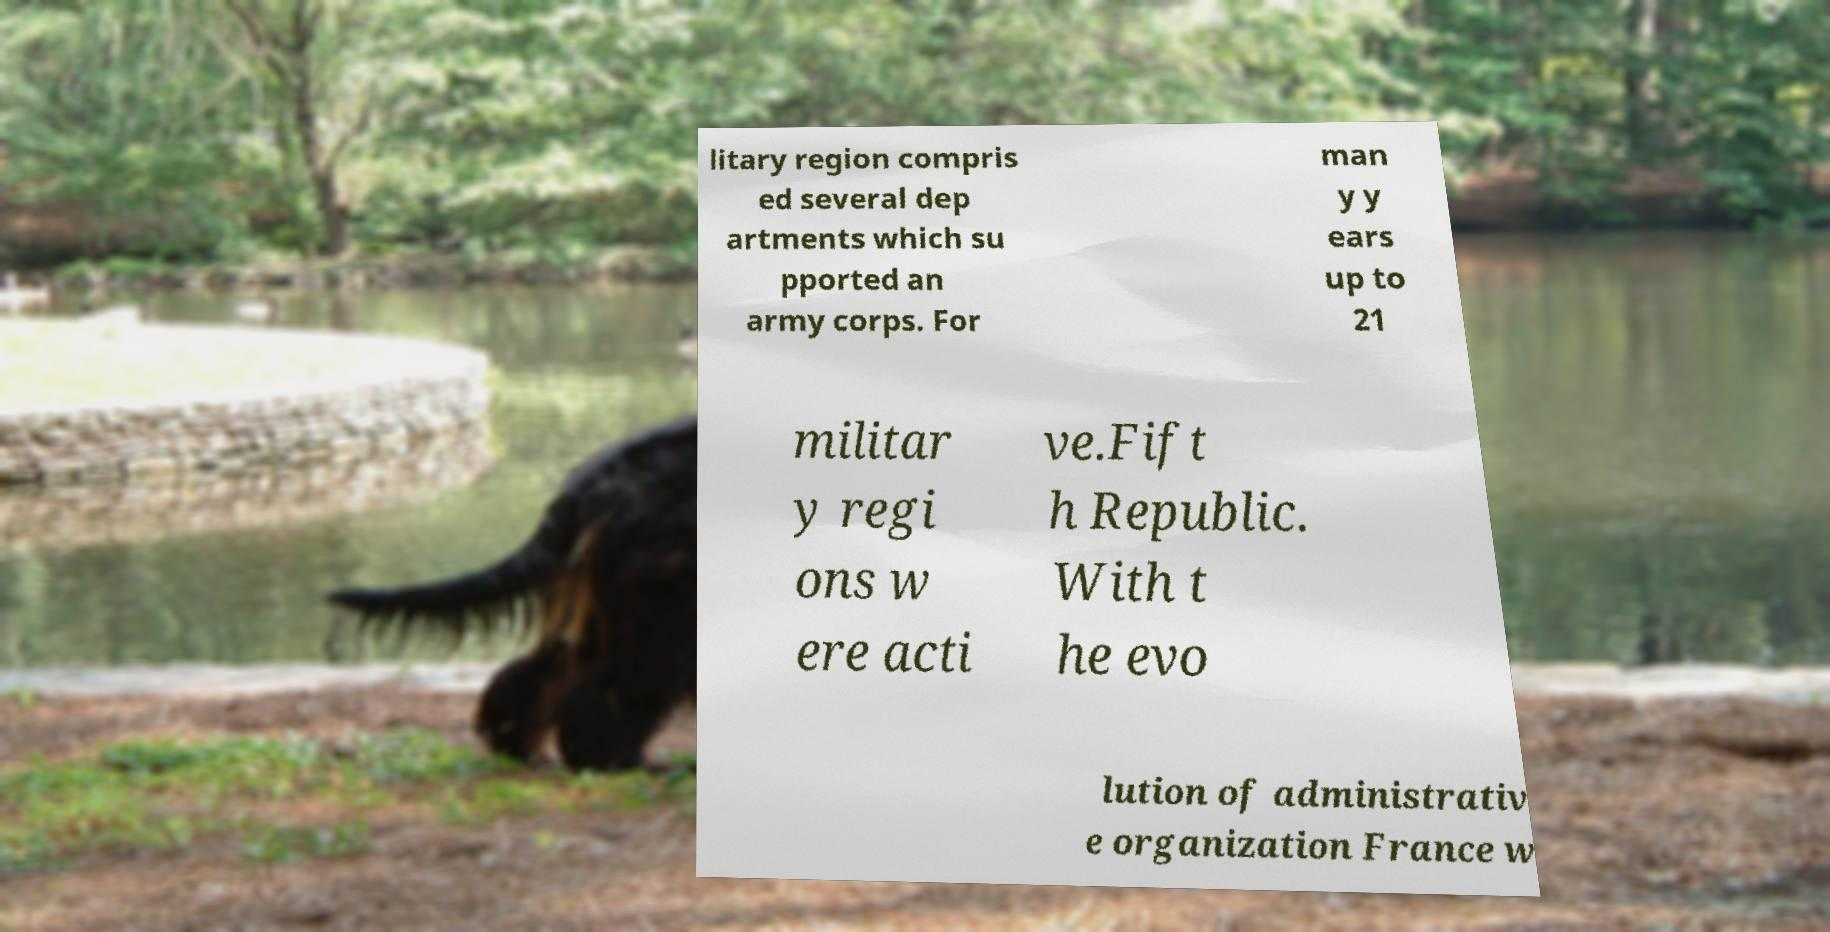I need the written content from this picture converted into text. Can you do that? litary region compris ed several dep artments which su pported an army corps. For man y y ears up to 21 militar y regi ons w ere acti ve.Fift h Republic. With t he evo lution of administrativ e organization France w 